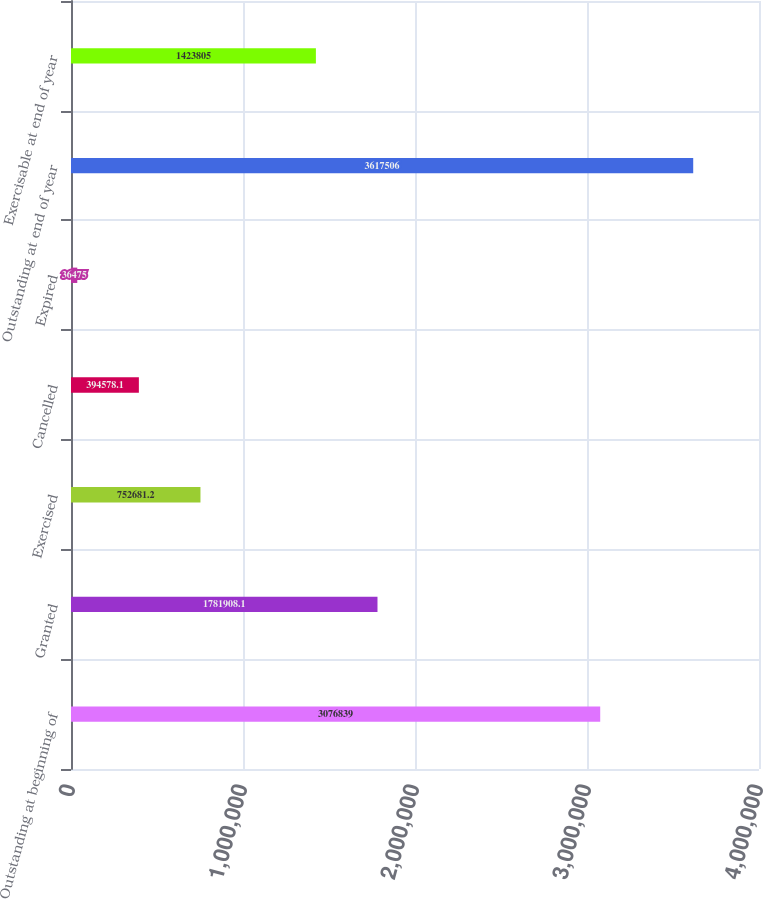<chart> <loc_0><loc_0><loc_500><loc_500><bar_chart><fcel>Outstanding at beginning of<fcel>Granted<fcel>Exercised<fcel>Cancelled<fcel>Expired<fcel>Outstanding at end of year<fcel>Exercisable at end of year<nl><fcel>3.07684e+06<fcel>1.78191e+06<fcel>752681<fcel>394578<fcel>36475<fcel>3.61751e+06<fcel>1.4238e+06<nl></chart> 